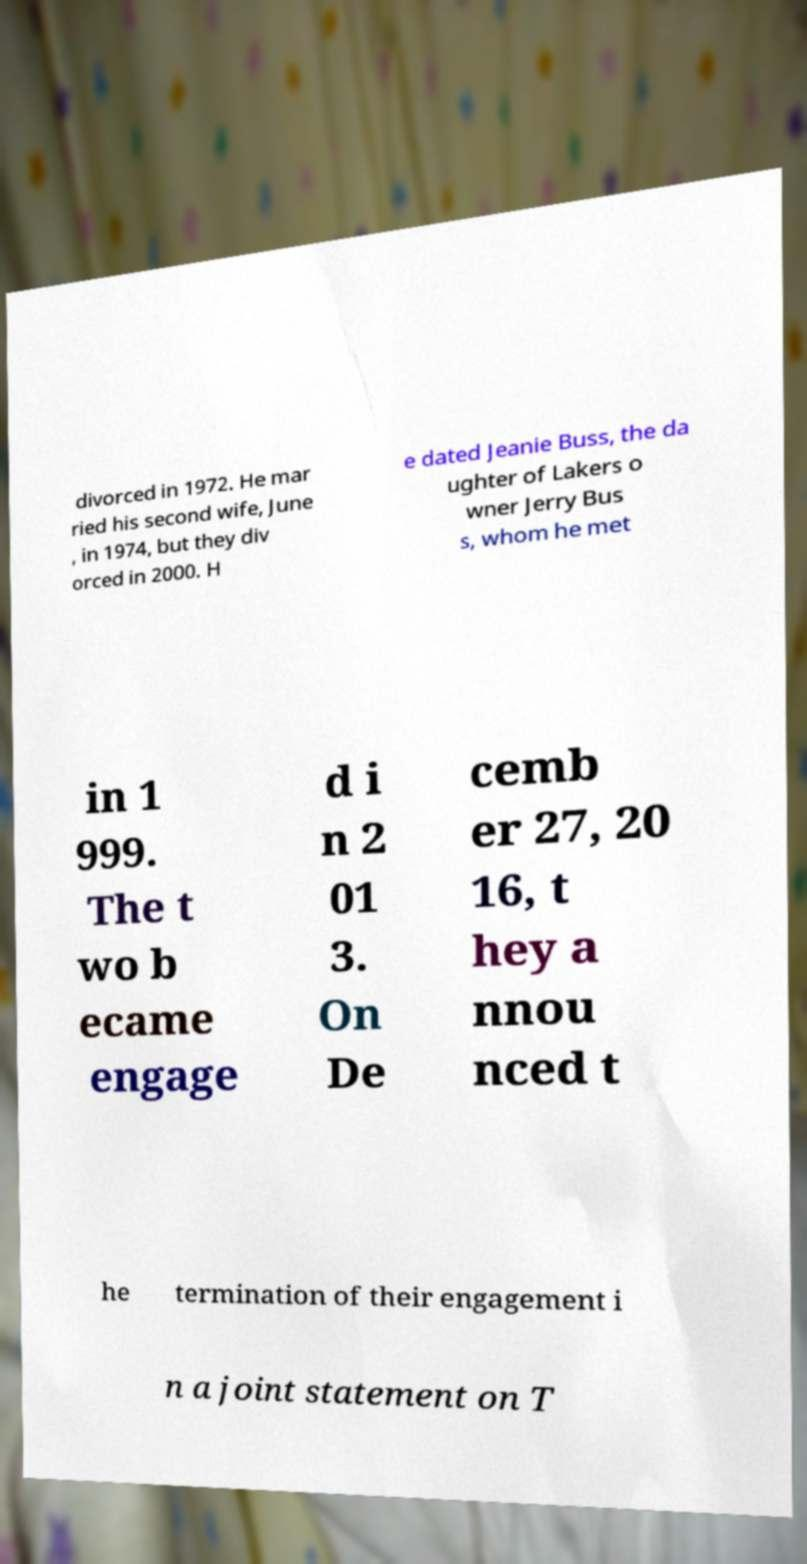Could you extract and type out the text from this image? divorced in 1972. He mar ried his second wife, June , in 1974, but they div orced in 2000. H e dated Jeanie Buss, the da ughter of Lakers o wner Jerry Bus s, whom he met in 1 999. The t wo b ecame engage d i n 2 01 3. On De cemb er 27, 20 16, t hey a nnou nced t he termination of their engagement i n a joint statement on T 